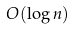<formula> <loc_0><loc_0><loc_500><loc_500>O ( \log n )</formula> 